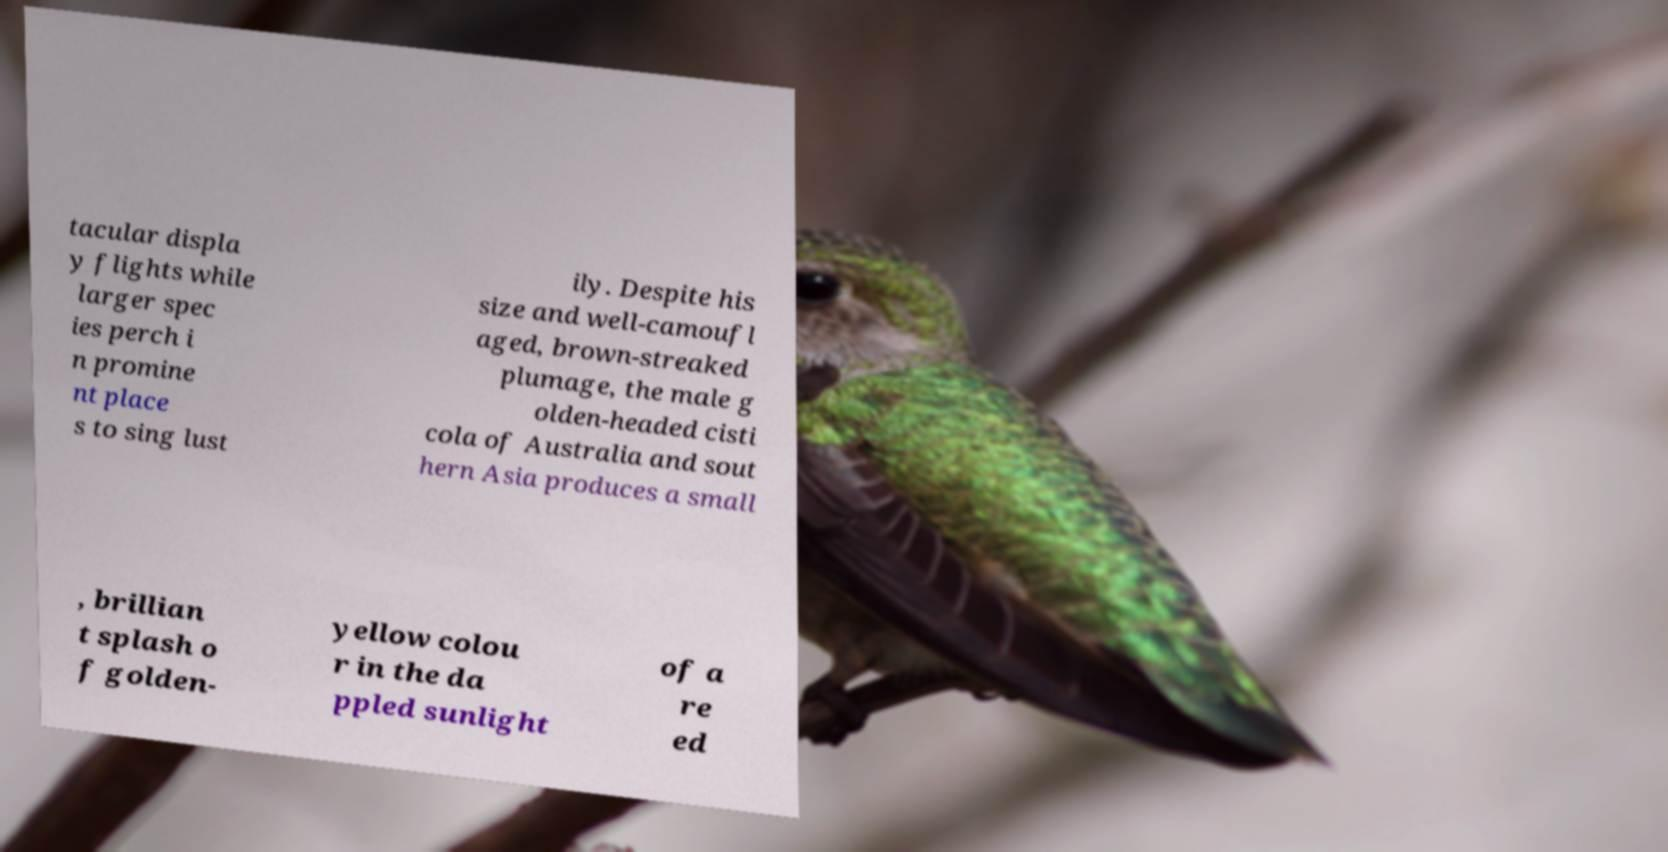For documentation purposes, I need the text within this image transcribed. Could you provide that? tacular displa y flights while larger spec ies perch i n promine nt place s to sing lust ily. Despite his size and well-camoufl aged, brown-streaked plumage, the male g olden-headed cisti cola of Australia and sout hern Asia produces a small , brillian t splash o f golden- yellow colou r in the da ppled sunlight of a re ed 